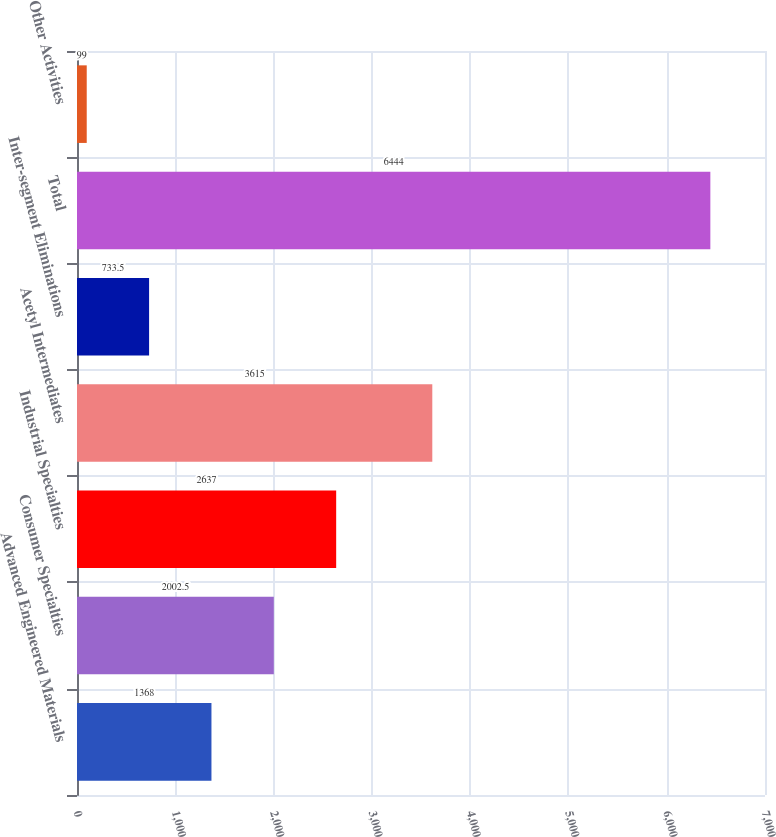Convert chart to OTSL. <chart><loc_0><loc_0><loc_500><loc_500><bar_chart><fcel>Advanced Engineered Materials<fcel>Consumer Specialties<fcel>Industrial Specialties<fcel>Acetyl Intermediates<fcel>Inter-segment Eliminations<fcel>Total<fcel>Other Activities<nl><fcel>1368<fcel>2002.5<fcel>2637<fcel>3615<fcel>733.5<fcel>6444<fcel>99<nl></chart> 